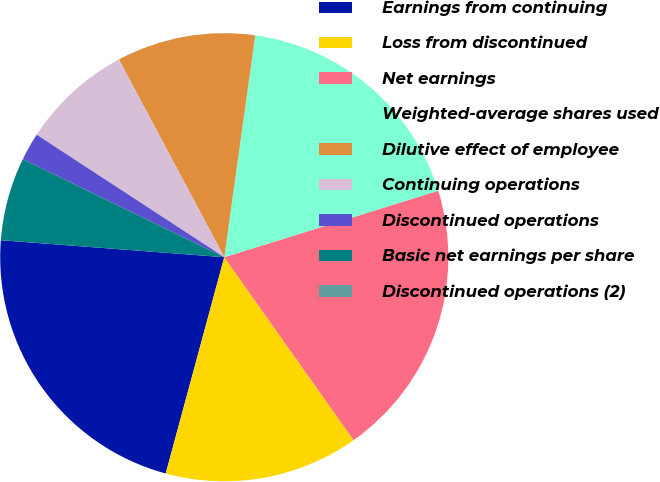<chart> <loc_0><loc_0><loc_500><loc_500><pie_chart><fcel>Earnings from continuing<fcel>Loss from discontinued<fcel>Net earnings<fcel>Weighted-average shares used<fcel>Dilutive effect of employee<fcel>Continuing operations<fcel>Discontinued operations<fcel>Basic net earnings per share<fcel>Discontinued operations (2)<nl><fcel>22.0%<fcel>14.0%<fcel>20.0%<fcel>18.0%<fcel>10.0%<fcel>8.0%<fcel>2.0%<fcel>6.0%<fcel>0.0%<nl></chart> 